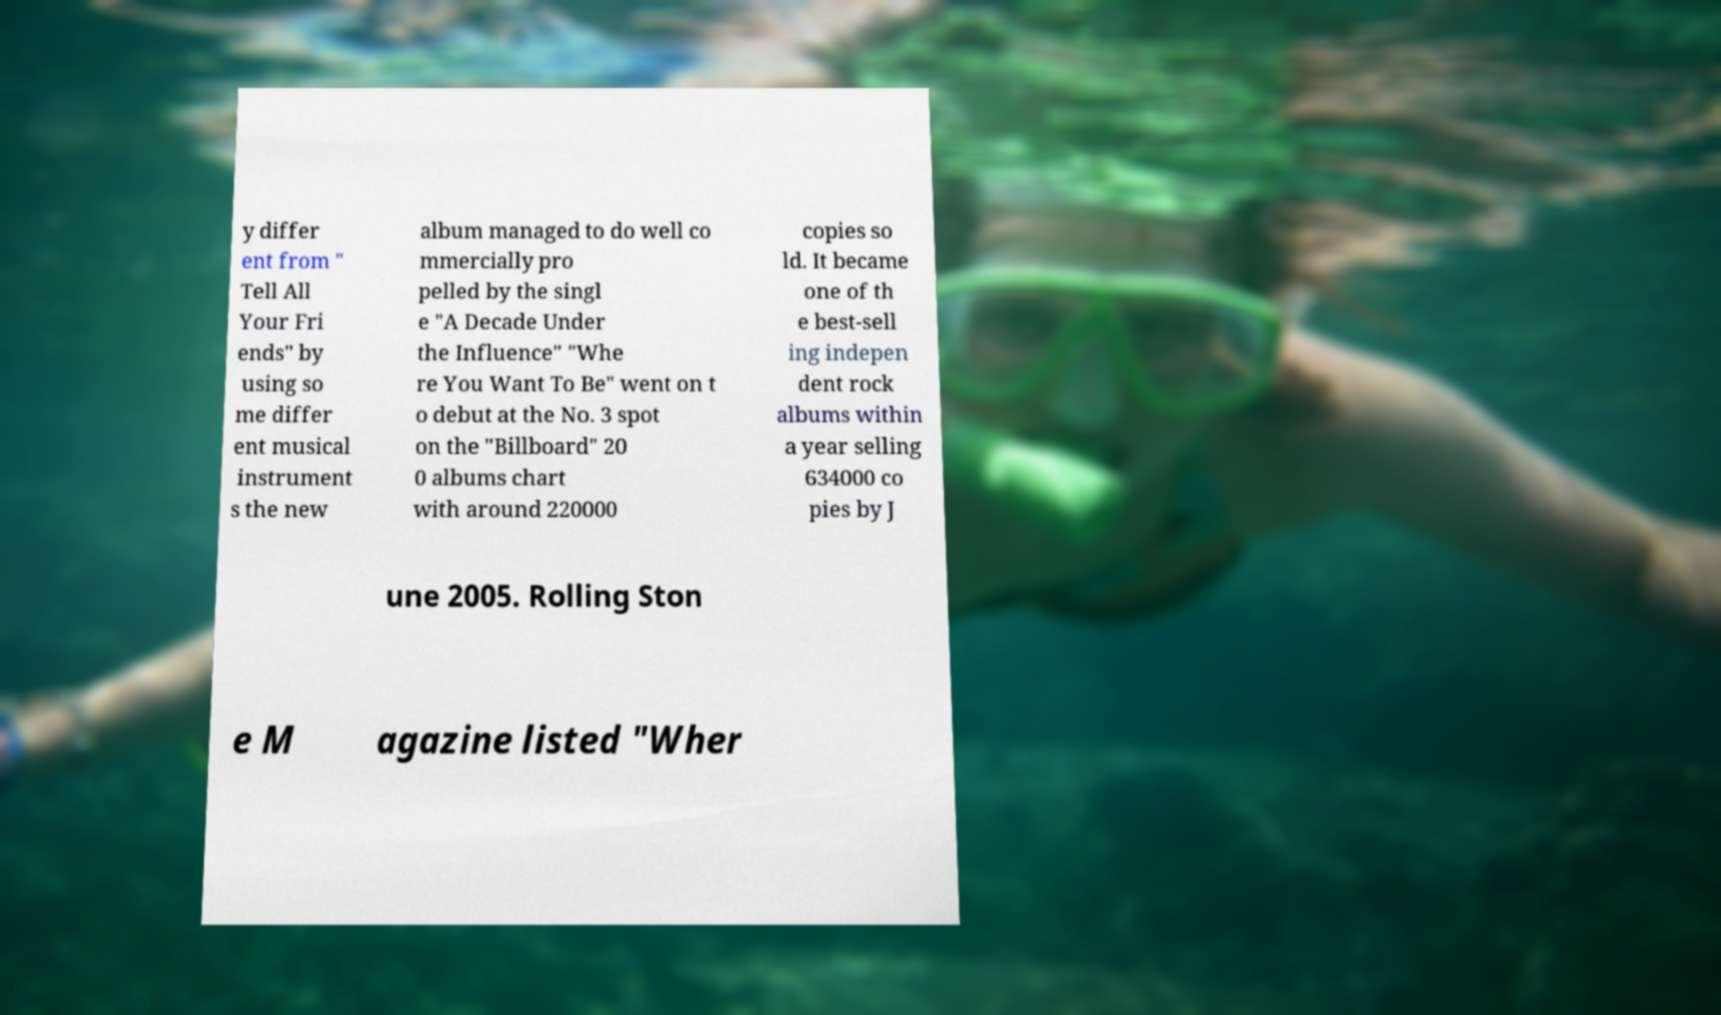What messages or text are displayed in this image? I need them in a readable, typed format. y differ ent from " Tell All Your Fri ends" by using so me differ ent musical instrument s the new album managed to do well co mmercially pro pelled by the singl e "A Decade Under the Influence" "Whe re You Want To Be" went on t o debut at the No. 3 spot on the "Billboard" 20 0 albums chart with around 220000 copies so ld. It became one of th e best-sell ing indepen dent rock albums within a year selling 634000 co pies by J une 2005. Rolling Ston e M agazine listed "Wher 